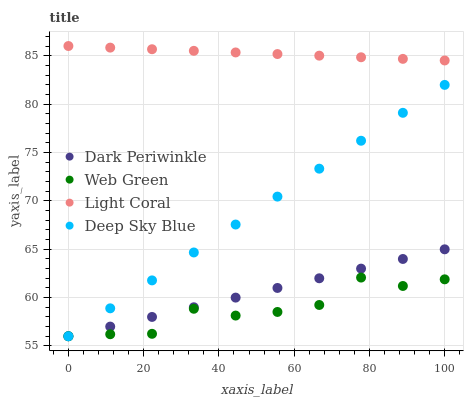Does Web Green have the minimum area under the curve?
Answer yes or no. Yes. Does Light Coral have the maximum area under the curve?
Answer yes or no. Yes. Does Deep Sky Blue have the minimum area under the curve?
Answer yes or no. No. Does Deep Sky Blue have the maximum area under the curve?
Answer yes or no. No. Is Dark Periwinkle the smoothest?
Answer yes or no. Yes. Is Web Green the roughest?
Answer yes or no. Yes. Is Deep Sky Blue the smoothest?
Answer yes or no. No. Is Deep Sky Blue the roughest?
Answer yes or no. No. Does Deep Sky Blue have the lowest value?
Answer yes or no. Yes. Does Light Coral have the highest value?
Answer yes or no. Yes. Does Deep Sky Blue have the highest value?
Answer yes or no. No. Is Dark Periwinkle less than Light Coral?
Answer yes or no. Yes. Is Light Coral greater than Dark Periwinkle?
Answer yes or no. Yes. Does Web Green intersect Deep Sky Blue?
Answer yes or no. Yes. Is Web Green less than Deep Sky Blue?
Answer yes or no. No. Is Web Green greater than Deep Sky Blue?
Answer yes or no. No. Does Dark Periwinkle intersect Light Coral?
Answer yes or no. No. 